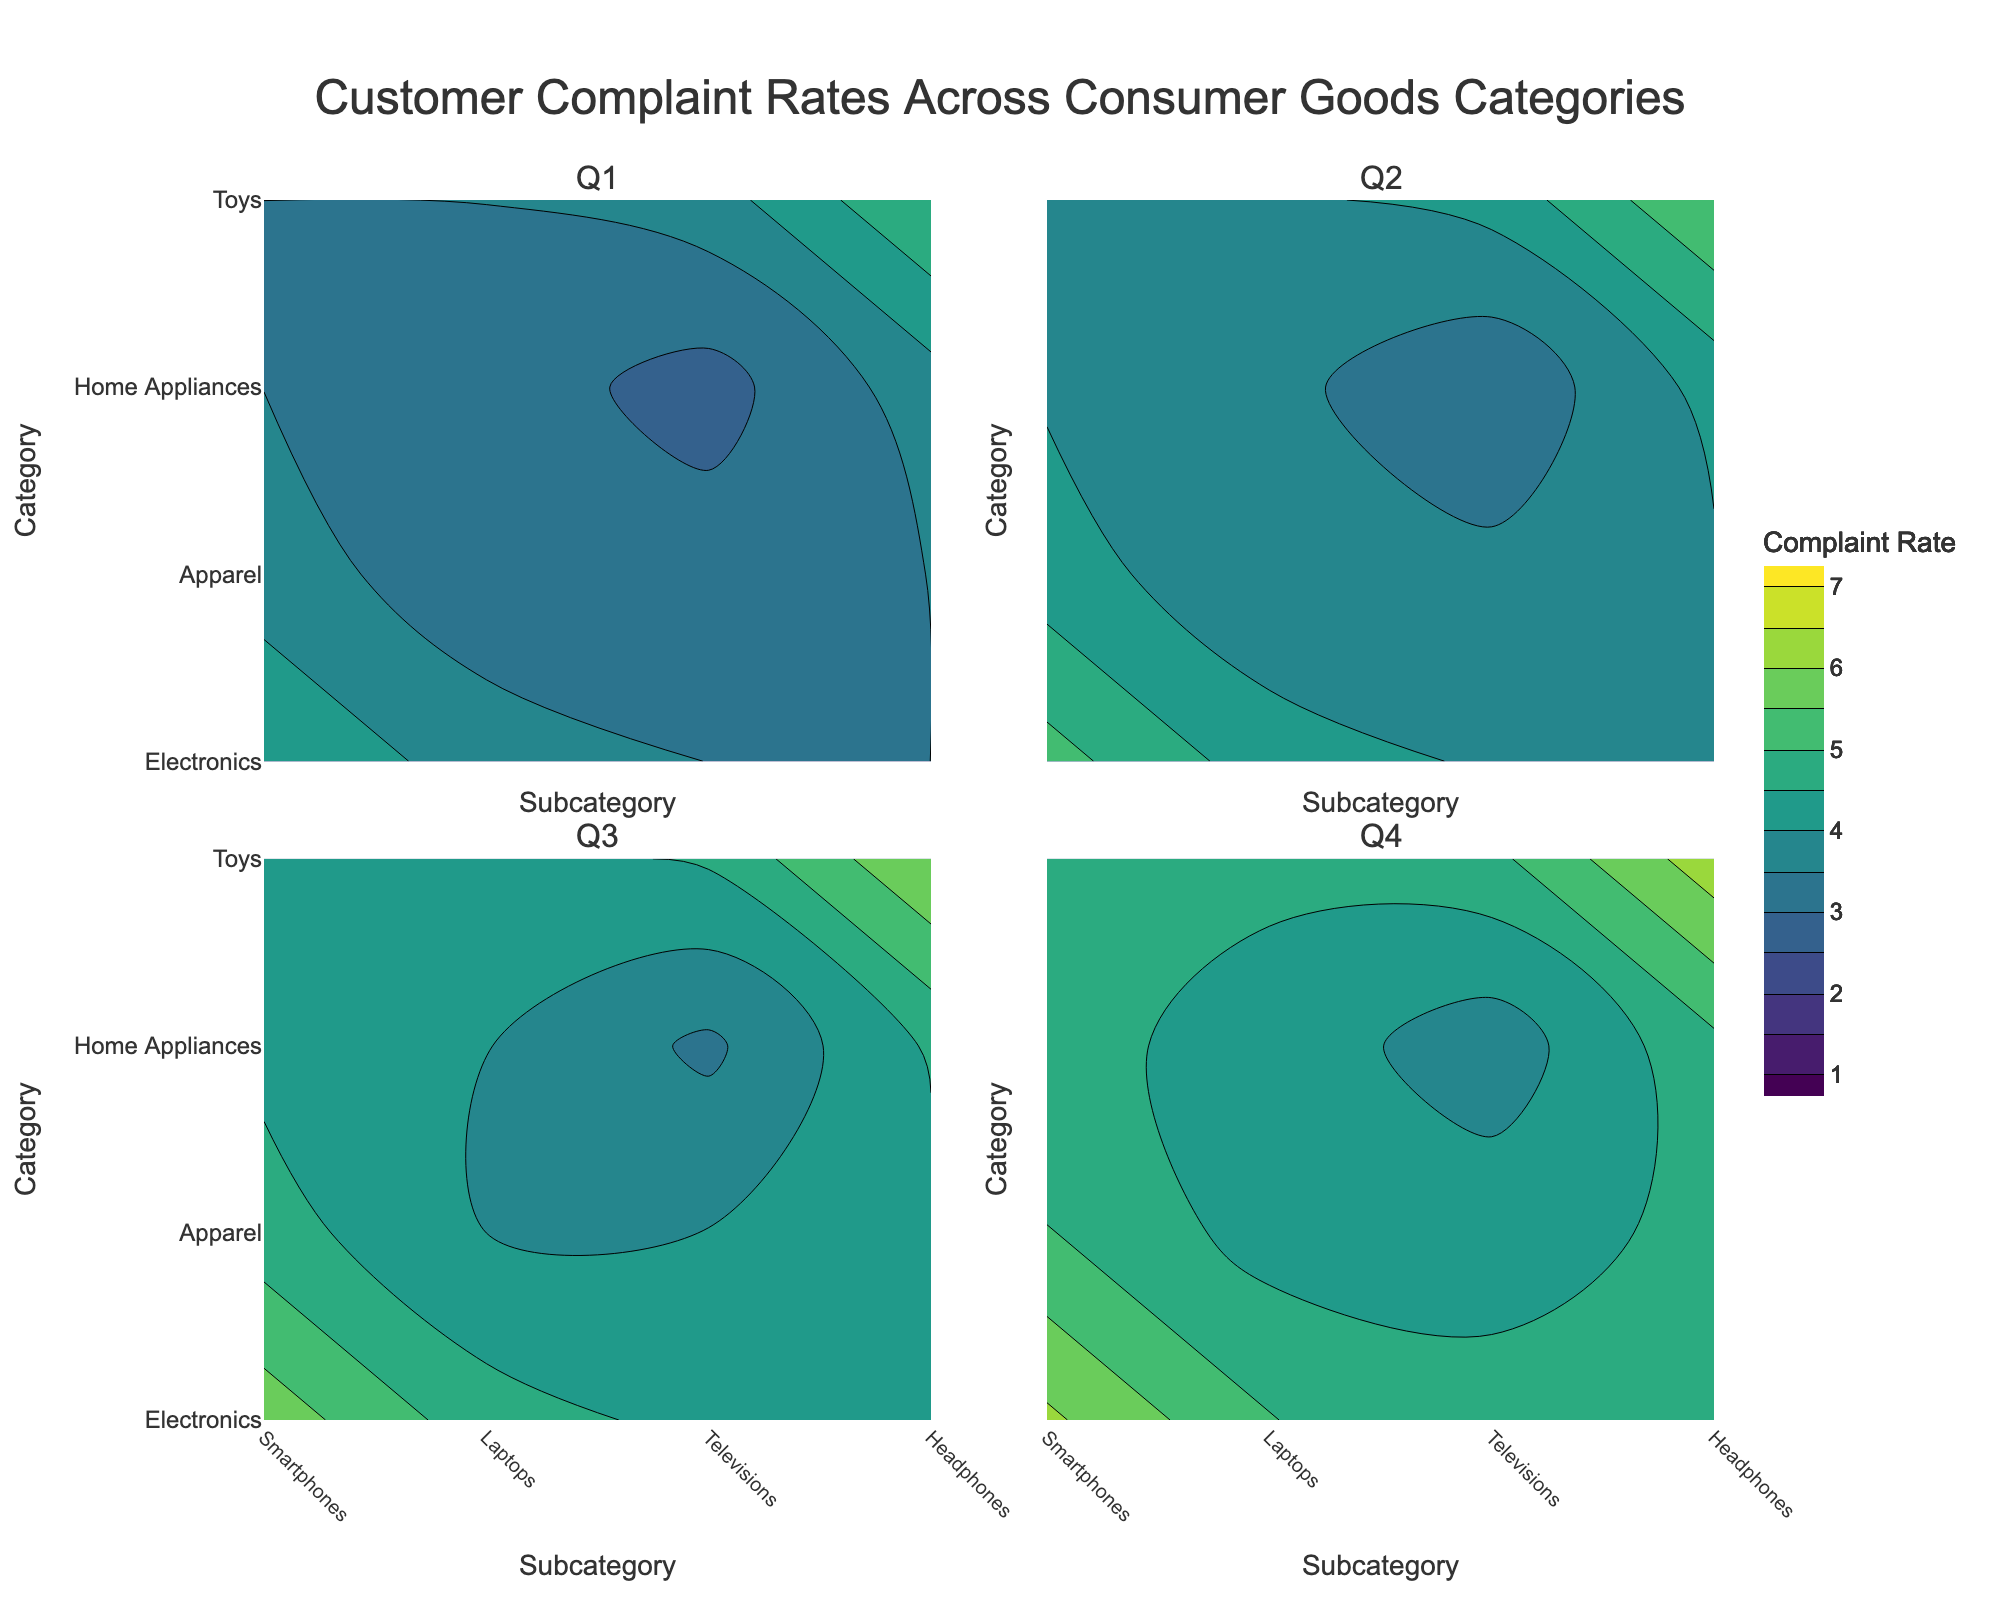What categories are used in the figure? The categories are listed on the y-axis of the contour plots. They include Electronics, Apparel, Home Appliances, and Toys.
Answer: Electronics, Apparel, Home Appliances, Toys Which subcategories from the "Electronics" category have the highest complaint rates in Q1? By examining the contour plot for Q1, we can see the complaint rates for subcategories under Electronics. Headphones have the highest complaint rates.
Answer: Headphones How do complaint rates for "Smartphones" change across the quarters? By observing the change in contours for Smartphones across the four plots (Q1 to Q4), the complaint rates increase: Q1 (4.5), Q2 (5.2), Q3 (5.8), Q4 (6.1).
Answer: Increase Which quarter shows the highest overall complaint rates for the "Toys" category? By comparing the contour heights for each Toys subcategory across all quarters, Q4 has the highest overall values.
Answer: Q4 What is the average complaint rate for "Menswear" across all quarters? The complaint rates for Menswear across Q1 to Q4 are 2.1, 2.5, 2.9, and 3.0. The average is calculated as (2.1 + 2.5 + 2.9 + 3.0) / 4.
Answer: 2.63 Which subcategory under "Home Appliances" has the lowest complaint rate in Q1? Looking at the contour plot for Q1, Microwaves have the lowest complaint rate among Home Appliances.
Answer: Microwaves Do "Vacuums" have higher complaint rates in Q4 than "Refrigerators"? By inspecting the Q4 contour plot, Vacuums have a complaint rate of 2.9, which is higher than Refrigerators' 3.2.
Answer: No Is the complaint rate for "Electronic Toys" higher than "Smartphones" in Q4? Checking the Q4 contours for both subcategories, Electronic Toys have a complaint rate of 5.2, which is lower than Smartphones’ 6.1.
Answer: No How do the complaint rates for "Womenswear" compare across Q2 and Q3? By examining the values in the contours, the complaint rates for Womenswear are 2.2 in Q2 and 2.5 in Q3, showing an increase.
Answer: Increase Which subcategory has the most significant increase in complaint rates from Q1 to Q4? By comparing the increases across all subcategories between Q1 and Q4, Smartphones show an increase from 4.5 to 6.1, which is notable.
Answer: Smartphones 